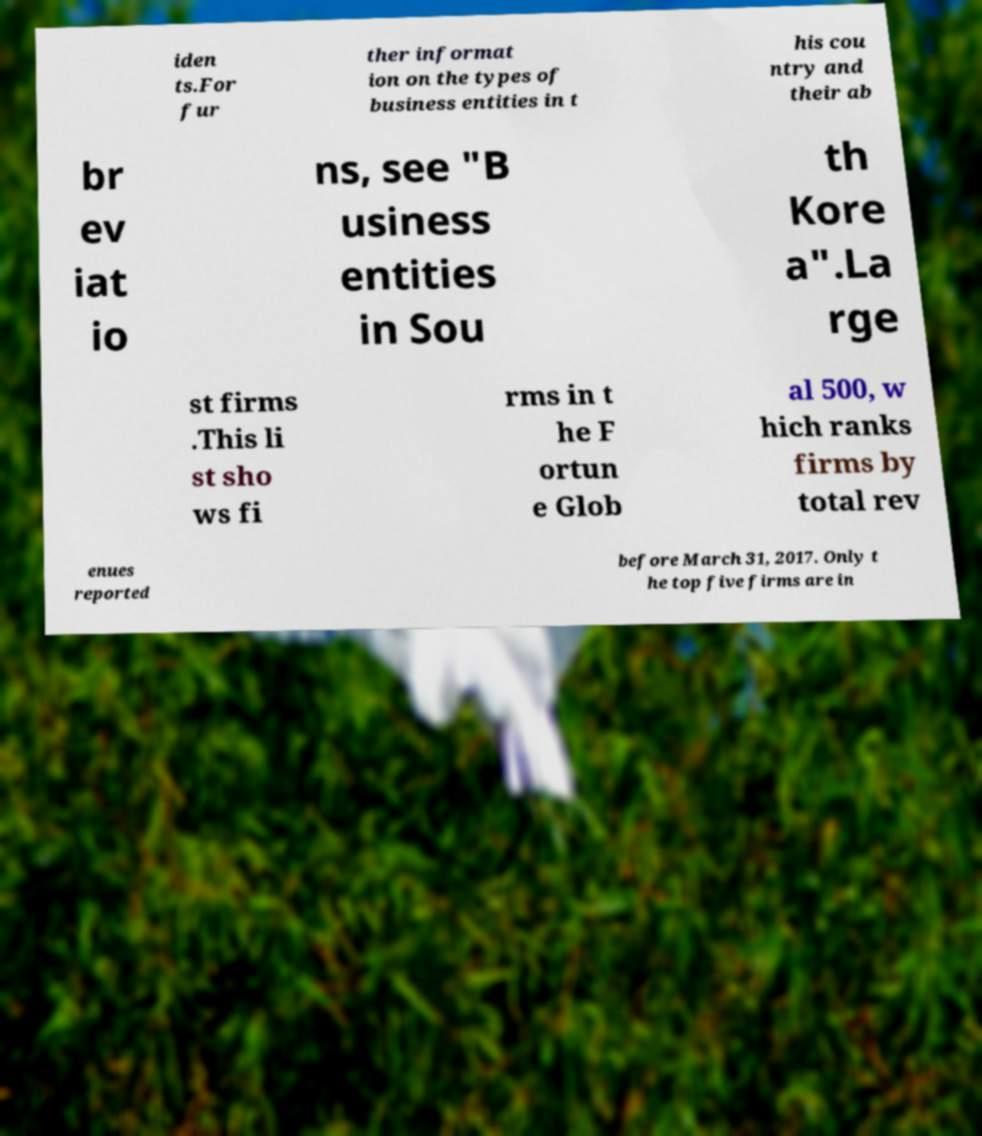There's text embedded in this image that I need extracted. Can you transcribe it verbatim? iden ts.For fur ther informat ion on the types of business entities in t his cou ntry and their ab br ev iat io ns, see "B usiness entities in Sou th Kore a".La rge st firms .This li st sho ws fi rms in t he F ortun e Glob al 500, w hich ranks firms by total rev enues reported before March 31, 2017. Only t he top five firms are in 